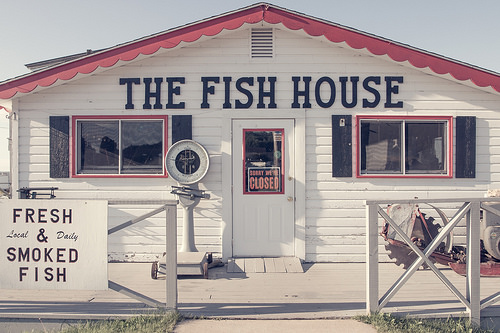<image>
Can you confirm if the sign is in front of the other sign? No. The sign is not in front of the other sign. The spatial positioning shows a different relationship between these objects. 